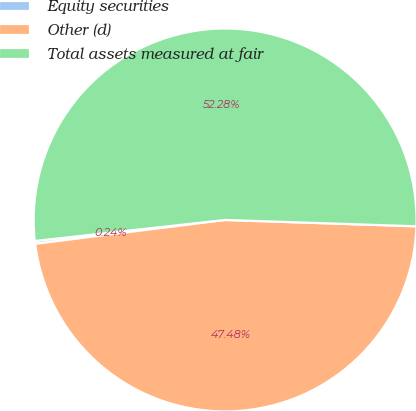<chart> <loc_0><loc_0><loc_500><loc_500><pie_chart><fcel>Equity securities<fcel>Other (d)<fcel>Total assets measured at fair<nl><fcel>0.24%<fcel>47.48%<fcel>52.28%<nl></chart> 